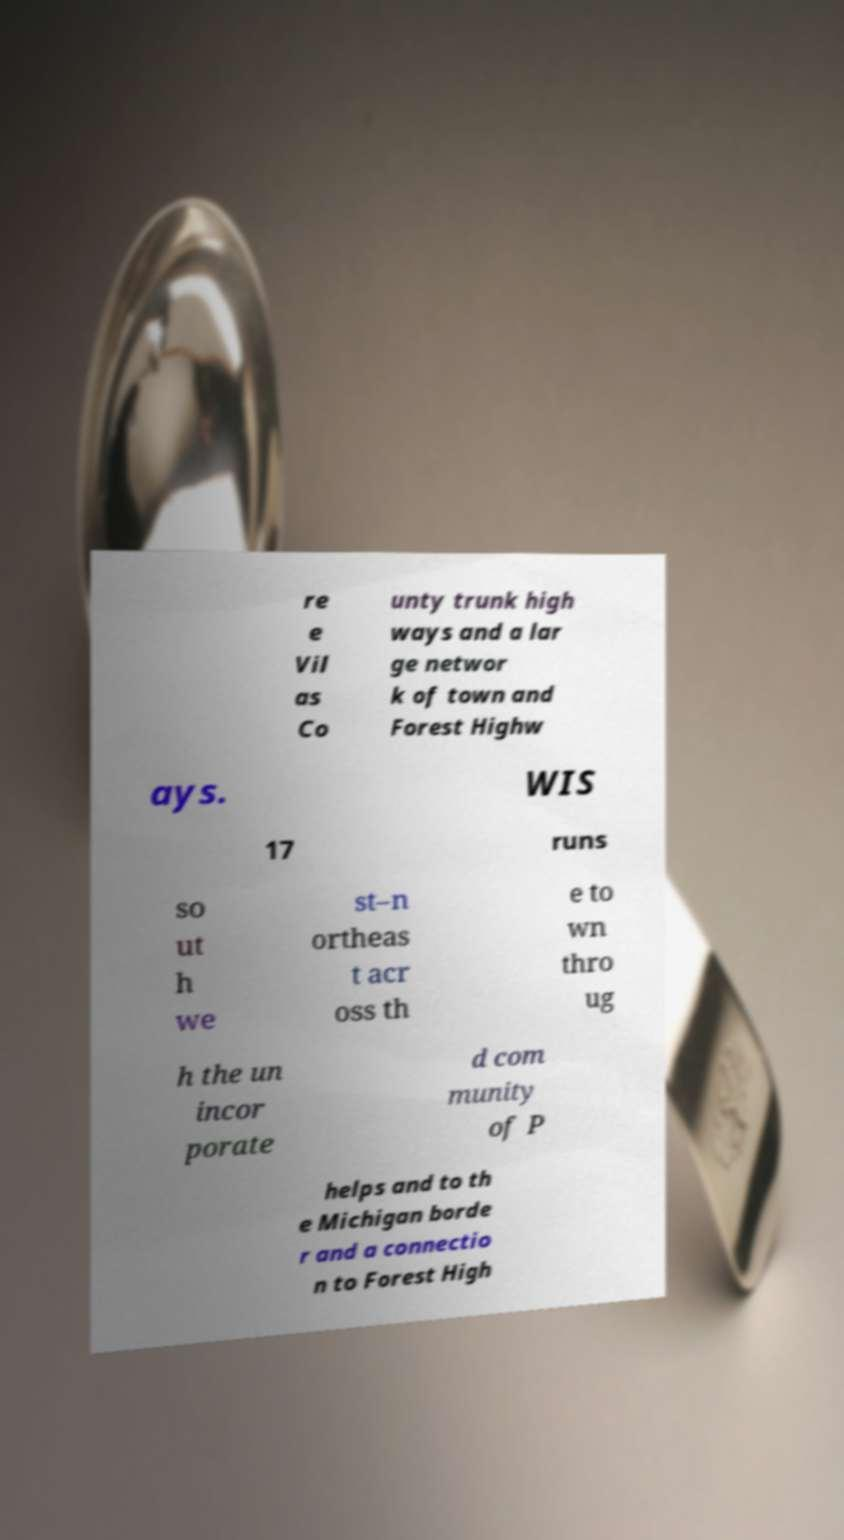Could you extract and type out the text from this image? re e Vil as Co unty trunk high ways and a lar ge networ k of town and Forest Highw ays. WIS 17 runs so ut h we st–n ortheas t acr oss th e to wn thro ug h the un incor porate d com munity of P helps and to th e Michigan borde r and a connectio n to Forest High 